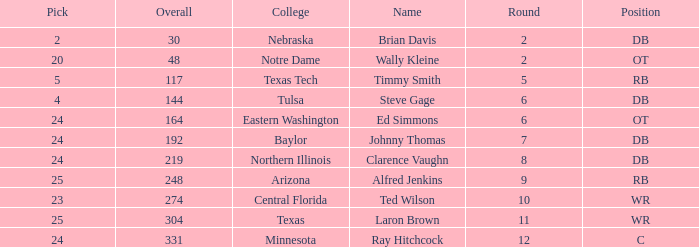What top round has a pick smaller than 2? None. 